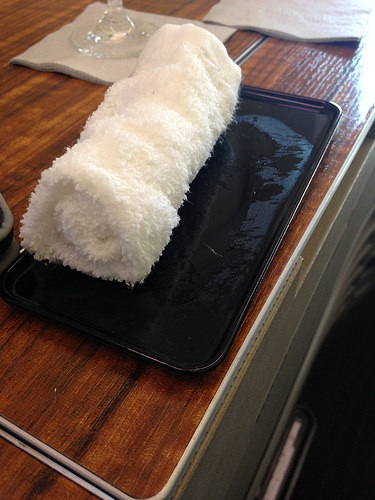<image>
Can you confirm if the towel is behind the table? No. The towel is not behind the table. From this viewpoint, the towel appears to be positioned elsewhere in the scene. Is the towel on the mobile? Yes. Looking at the image, I can see the towel is positioned on top of the mobile, with the mobile providing support. 